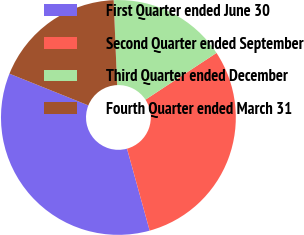Convert chart. <chart><loc_0><loc_0><loc_500><loc_500><pie_chart><fcel>First Quarter ended June 30<fcel>Second Quarter ended September<fcel>Third Quarter ended December<fcel>Fourth Quarter ended March 31<nl><fcel>35.37%<fcel>29.97%<fcel>16.38%<fcel>18.28%<nl></chart> 